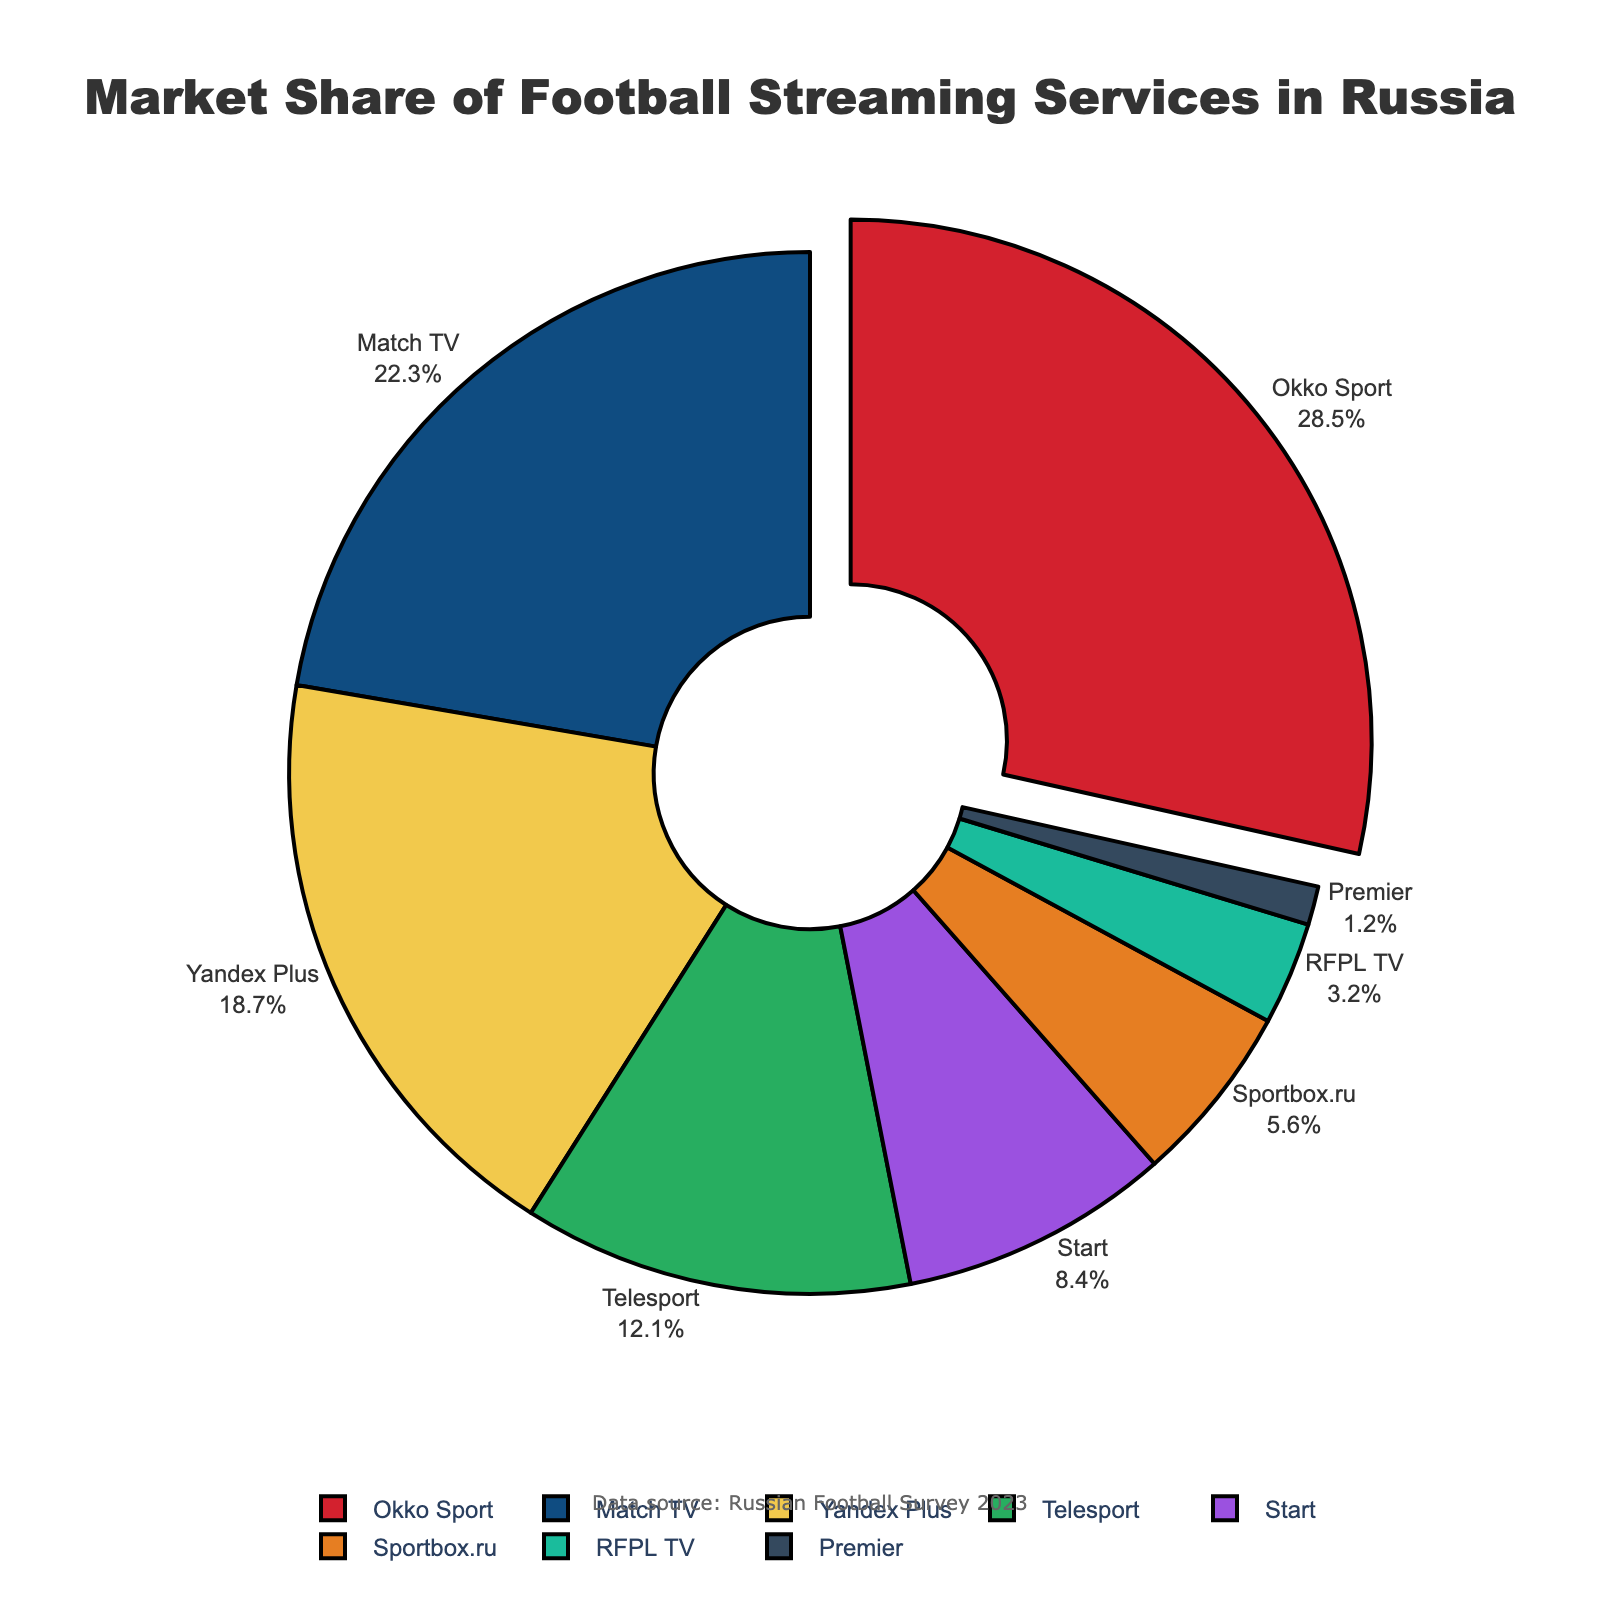Which football streaming service has the largest market share? The pie chart shows that the Okko Sport segment is pulled out slightly, highlighting it as having the largest market share. This is confirmed in the legend and label information.
Answer: Okko Sport Which two services have the closest market shares? By visually comparing the sizes of the pie slices and their market share percentages, Match TV and Yandex Plus have market shares of 22.3% and 18.7% respectively, which are closest to each other.
Answer: Match TV and Yandex Plus What is the combined market share of Telesport, Start, and Sportbox.ru? Telesport has a market share of 12.1%, Start has 8.4%, and Sportbox.ru has 5.6%. Adding them together: 12.1% + 8.4% + 5.6% = 26.1%.
Answer: 26.1% How much more market share does Okko Sport have than Premier? Okko Sport has a market share of 28.5%, while Premier has 1.2%. The difference is calculated as 28.5% - 1.2% = 27.3%.
Answer: 27.3% Which service has the smallest market share, and what is its percentage? The pie chart and the visual labeling indicate that Premier has the smallest market share with 1.2%.
Answer: Premier (1.2%) Which service is represented by the dark blue color? The pie chart's legend associates the dark blue color with Match TV.
Answer: Match TV List all services that have a market share greater than 20%. The labels on the pie chart indicate that Okko Sport (28.5%) and Match TV (22.3%) both have market shares greater than 20%.
Answer: Okko Sport and Match TV 